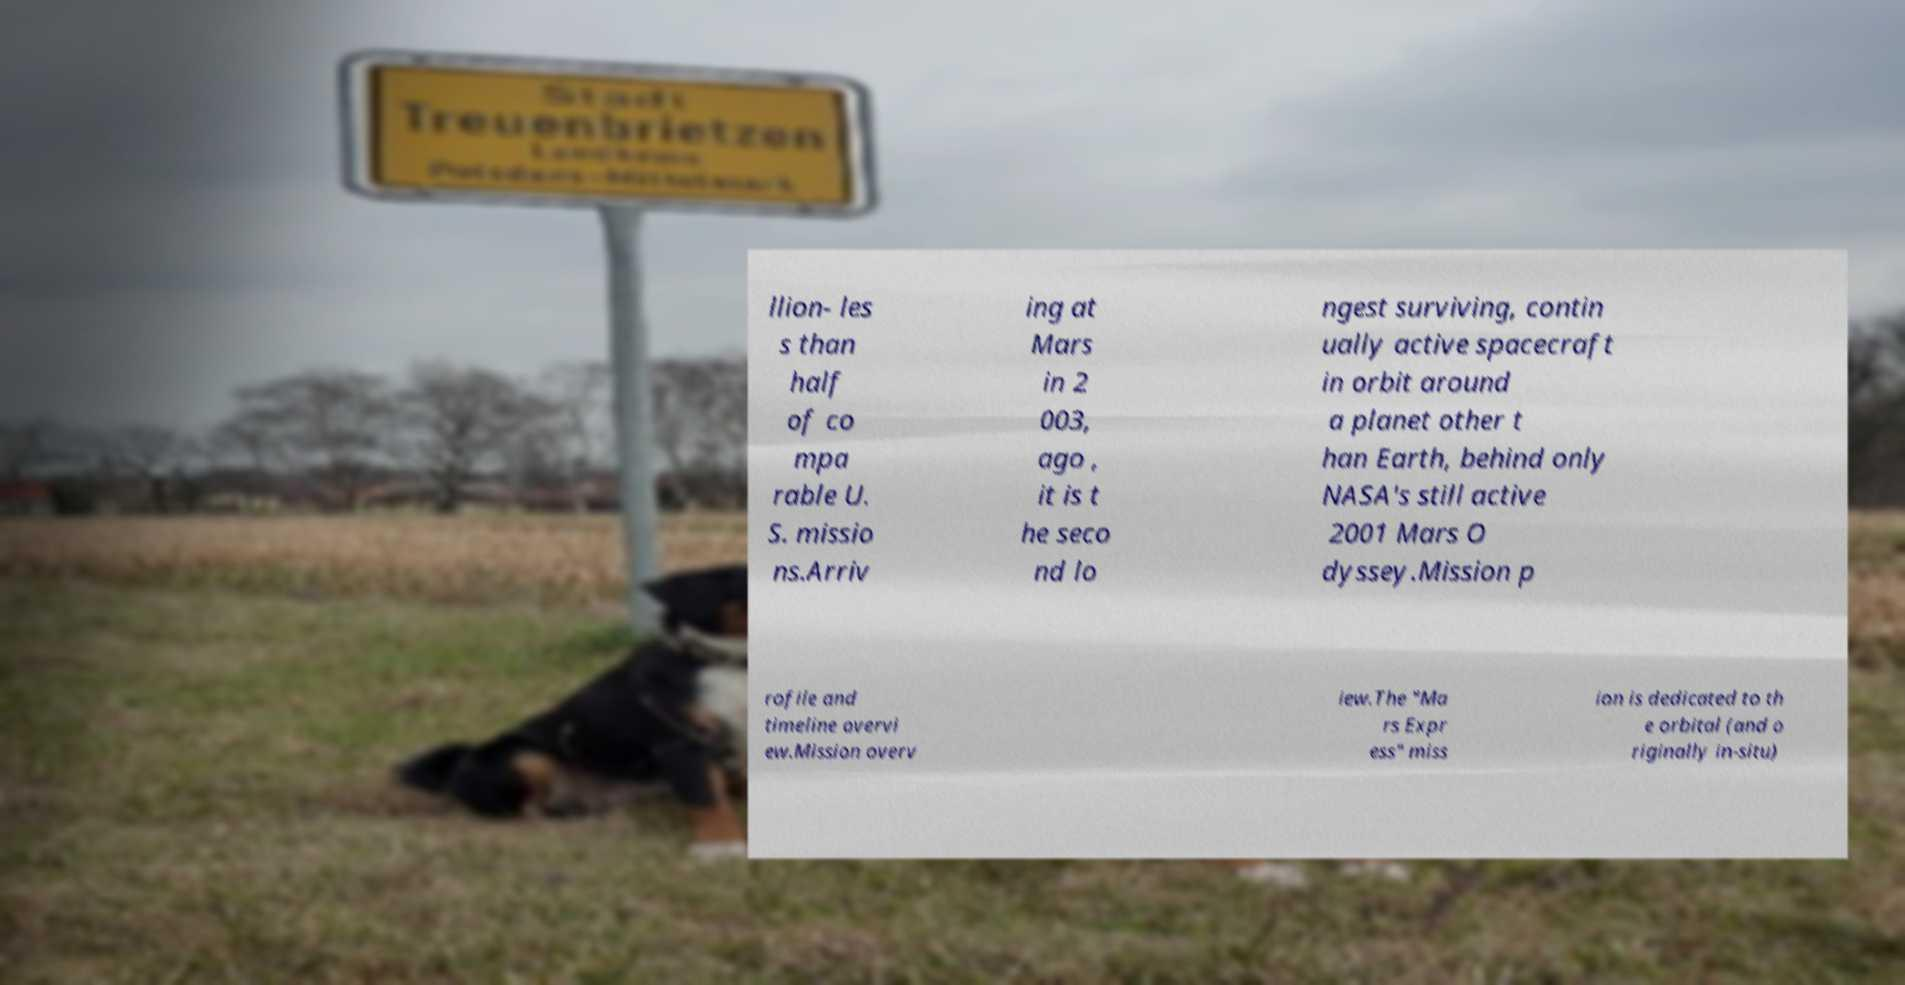Please read and relay the text visible in this image. What does it say? llion- les s than half of co mpa rable U. S. missio ns.Arriv ing at Mars in 2 003, ago , it is t he seco nd lo ngest surviving, contin ually active spacecraft in orbit around a planet other t han Earth, behind only NASA's still active 2001 Mars O dyssey.Mission p rofile and timeline overvi ew.Mission overv iew.The "Ma rs Expr ess" miss ion is dedicated to th e orbital (and o riginally in-situ) 